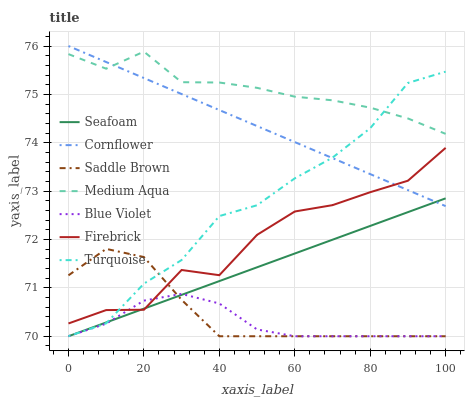Does Blue Violet have the minimum area under the curve?
Answer yes or no. Yes. Does Medium Aqua have the maximum area under the curve?
Answer yes or no. Yes. Does Turquoise have the minimum area under the curve?
Answer yes or no. No. Does Turquoise have the maximum area under the curve?
Answer yes or no. No. Is Cornflower the smoothest?
Answer yes or no. Yes. Is Firebrick the roughest?
Answer yes or no. Yes. Is Turquoise the smoothest?
Answer yes or no. No. Is Turquoise the roughest?
Answer yes or no. No. Does Turquoise have the lowest value?
Answer yes or no. Yes. Does Firebrick have the lowest value?
Answer yes or no. No. Does Cornflower have the highest value?
Answer yes or no. Yes. Does Turquoise have the highest value?
Answer yes or no. No. Is Firebrick less than Medium Aqua?
Answer yes or no. Yes. Is Medium Aqua greater than Firebrick?
Answer yes or no. Yes. Does Turquoise intersect Firebrick?
Answer yes or no. Yes. Is Turquoise less than Firebrick?
Answer yes or no. No. Is Turquoise greater than Firebrick?
Answer yes or no. No. Does Firebrick intersect Medium Aqua?
Answer yes or no. No. 